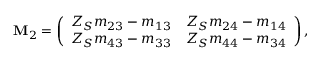Convert formula to latex. <formula><loc_0><loc_0><loc_500><loc_500>\mathbf M _ { 2 } = \left ( \begin{array} { c c } { Z _ { S } m _ { 2 3 } - m _ { 1 3 } } & { Z _ { S } m _ { 2 4 } - m _ { 1 4 } } \\ { Z _ { S } m _ { 4 3 } - m _ { 3 3 } } & { Z _ { S } m _ { 4 4 } - m _ { 3 4 } } \end{array} \right ) ,</formula> 